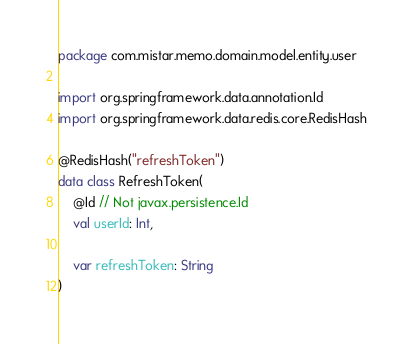<code> <loc_0><loc_0><loc_500><loc_500><_Kotlin_>package com.mistar.memo.domain.model.entity.user

import org.springframework.data.annotation.Id
import org.springframework.data.redis.core.RedisHash

@RedisHash("refreshToken")
data class RefreshToken(
    @Id // Not javax.persistence.Id
    val userId: Int,

    var refreshToken: String
)</code> 